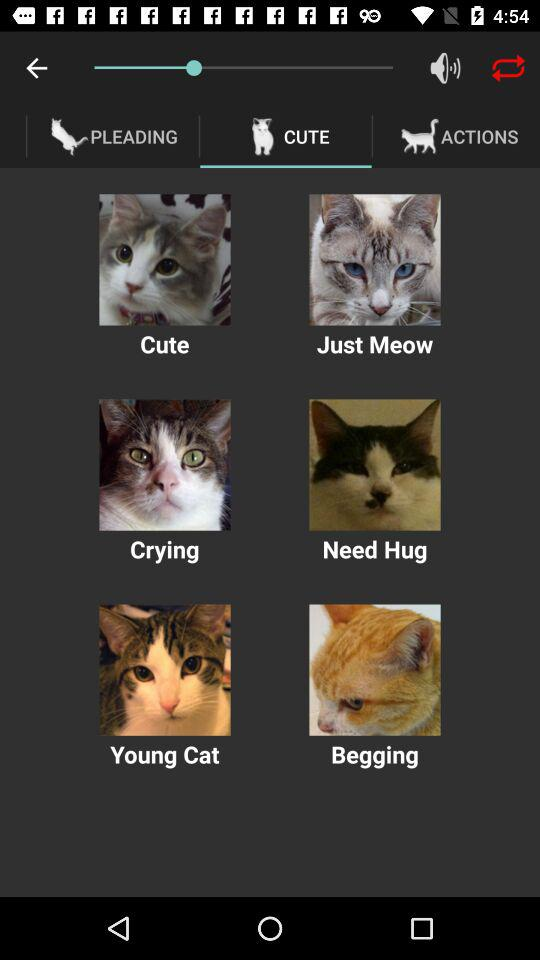Which images are in "ACTIONS"?
When the provided information is insufficient, respond with <no answer>. <no answer> 